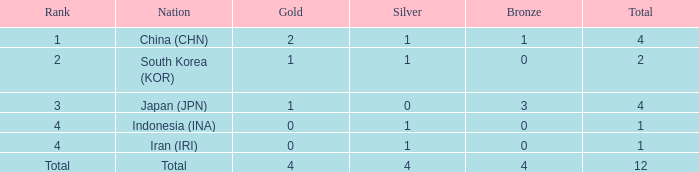Would you be able to parse every entry in this table? {'header': ['Rank', 'Nation', 'Gold', 'Silver', 'Bronze', 'Total'], 'rows': [['1', 'China (CHN)', '2', '1', '1', '4'], ['2', 'South Korea (KOR)', '1', '1', '0', '2'], ['3', 'Japan (JPN)', '1', '0', '3', '4'], ['4', 'Indonesia (INA)', '0', '1', '0', '1'], ['4', 'Iran (IRI)', '0', '1', '0', '1'], ['Total', 'Total', '4', '4', '4', '12']]} What is the fewest gold medals for the nation with 4 silvers and more than 4 bronze? None. 